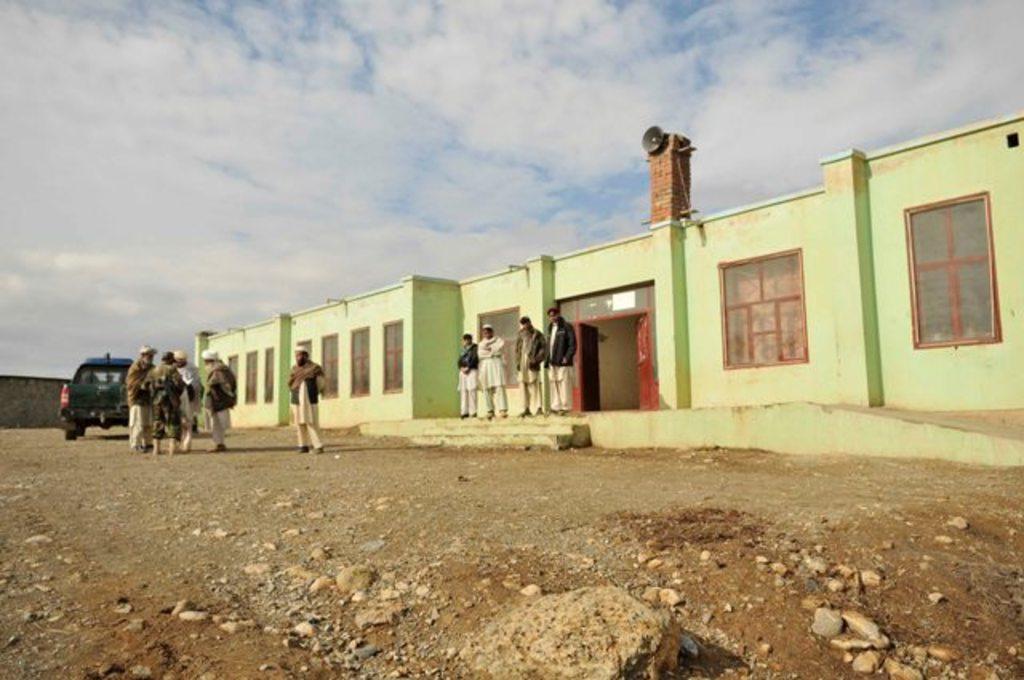Can you describe this image briefly? In this image we can see a group of people standing on the ground. One person is wearing a uniform. In the background, we can see a building with windows, door, a horn on the wall and the sky. 